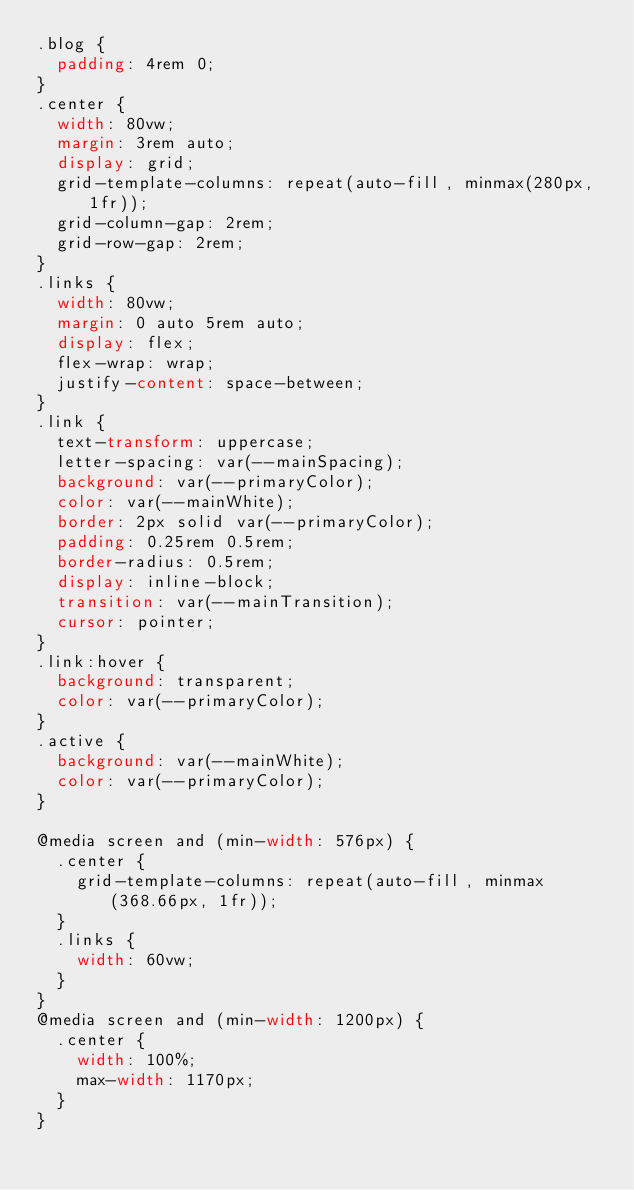Convert code to text. <code><loc_0><loc_0><loc_500><loc_500><_CSS_>.blog {
  padding: 4rem 0;
}
.center {
  width: 80vw;
  margin: 3rem auto;
  display: grid;
  grid-template-columns: repeat(auto-fill, minmax(280px, 1fr));
  grid-column-gap: 2rem;
  grid-row-gap: 2rem;
}
.links {
  width: 80vw;
  margin: 0 auto 5rem auto;
  display: flex;
  flex-wrap: wrap;
  justify-content: space-between;
}
.link {
  text-transform: uppercase;
  letter-spacing: var(--mainSpacing);
  background: var(--primaryColor);
  color: var(--mainWhite);
  border: 2px solid var(--primaryColor);
  padding: 0.25rem 0.5rem;
  border-radius: 0.5rem;
  display: inline-block;
  transition: var(--mainTransition);
  cursor: pointer;
}
.link:hover {
  background: transparent;
  color: var(--primaryColor);
}
.active {
  background: var(--mainWhite);
  color: var(--primaryColor);
}

@media screen and (min-width: 576px) {
  .center {
    grid-template-columns: repeat(auto-fill, minmax(368.66px, 1fr));
  }
  .links {
    width: 60vw;
  }
}
@media screen and (min-width: 1200px) {
  .center {
    width: 100%;
    max-width: 1170px;
  }
}</code> 